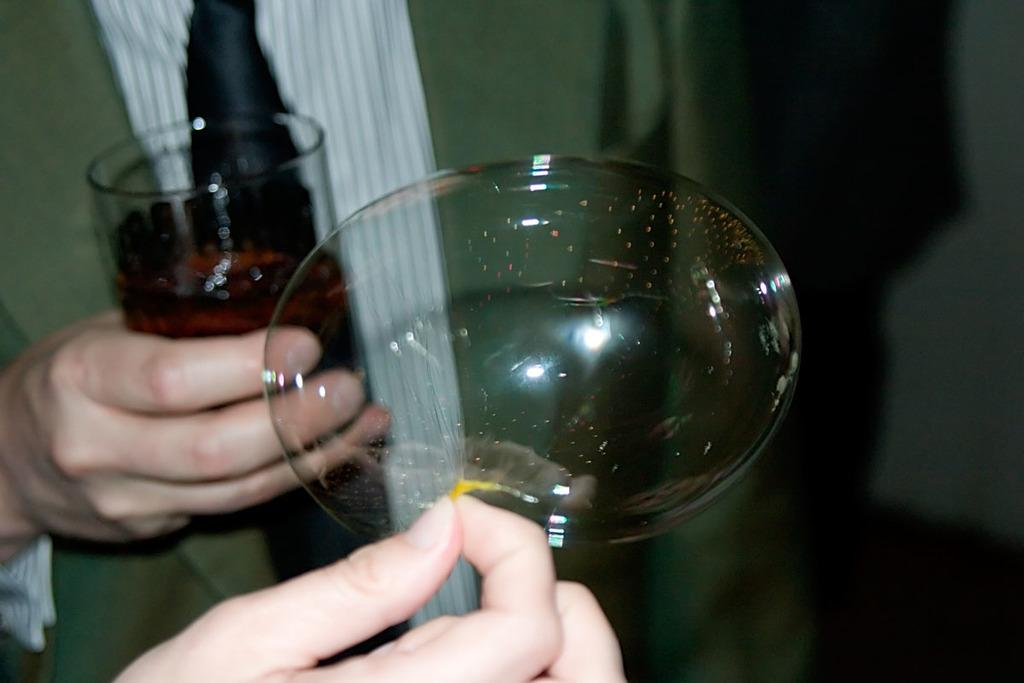What is the main subject of the image? There is a human in the image. What is the human holding in his hand? The human is holding a glass in his hand. Can you describe the contents of the glass? There is an air bubble in the glass. Are there any other human elements visible in the image? Yes, there is another human hand visible in the image. What type of donkey can be seen walking in the background of the image? There is no donkey present in the image, nor is there any indication of a background. Is there a tent visible in the image? No, there is no tent present in the image. 